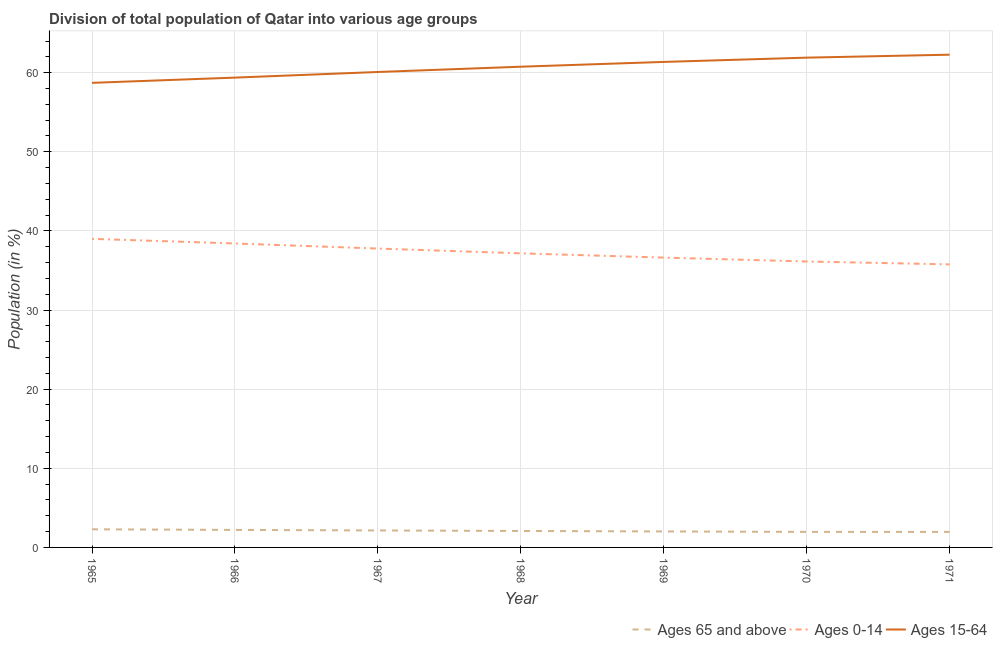How many different coloured lines are there?
Offer a terse response. 3. Does the line corresponding to percentage of population within the age-group of 65 and above intersect with the line corresponding to percentage of population within the age-group 15-64?
Keep it short and to the point. No. Is the number of lines equal to the number of legend labels?
Your answer should be compact. Yes. What is the percentage of population within the age-group 15-64 in 1966?
Your answer should be compact. 59.37. Across all years, what is the maximum percentage of population within the age-group of 65 and above?
Make the answer very short. 2.29. Across all years, what is the minimum percentage of population within the age-group of 65 and above?
Offer a terse response. 1.96. In which year was the percentage of population within the age-group of 65 and above maximum?
Keep it short and to the point. 1965. In which year was the percentage of population within the age-group 0-14 minimum?
Ensure brevity in your answer.  1971. What is the total percentage of population within the age-group 15-64 in the graph?
Offer a very short reply. 424.45. What is the difference between the percentage of population within the age-group 0-14 in 1967 and that in 1969?
Keep it short and to the point. 1.14. What is the difference between the percentage of population within the age-group 0-14 in 1971 and the percentage of population within the age-group 15-64 in 1966?
Your answer should be compact. -23.61. What is the average percentage of population within the age-group 15-64 per year?
Offer a terse response. 60.64. In the year 1969, what is the difference between the percentage of population within the age-group of 65 and above and percentage of population within the age-group 0-14?
Keep it short and to the point. -34.61. What is the ratio of the percentage of population within the age-group 15-64 in 1967 to that in 1970?
Give a very brief answer. 0.97. Is the percentage of population within the age-group 15-64 in 1965 less than that in 1971?
Ensure brevity in your answer.  Yes. What is the difference between the highest and the second highest percentage of population within the age-group 0-14?
Provide a succinct answer. 0.59. What is the difference between the highest and the lowest percentage of population within the age-group 15-64?
Give a very brief answer. 3.56. Is the percentage of population within the age-group 0-14 strictly greater than the percentage of population within the age-group of 65 and above over the years?
Ensure brevity in your answer.  Yes. How many years are there in the graph?
Offer a very short reply. 7. Are the values on the major ticks of Y-axis written in scientific E-notation?
Keep it short and to the point. No. Does the graph contain any zero values?
Your answer should be compact. No. What is the title of the graph?
Provide a succinct answer. Division of total population of Qatar into various age groups
. What is the Population (in %) of Ages 65 and above in 1965?
Give a very brief answer. 2.29. What is the Population (in %) of Ages 0-14 in 1965?
Your response must be concise. 39. What is the Population (in %) of Ages 15-64 in 1965?
Offer a terse response. 58.71. What is the Population (in %) of Ages 65 and above in 1966?
Make the answer very short. 2.21. What is the Population (in %) of Ages 0-14 in 1966?
Your response must be concise. 38.41. What is the Population (in %) in Ages 15-64 in 1966?
Offer a terse response. 59.37. What is the Population (in %) of Ages 65 and above in 1967?
Provide a succinct answer. 2.14. What is the Population (in %) in Ages 0-14 in 1967?
Your answer should be very brief. 37.77. What is the Population (in %) of Ages 15-64 in 1967?
Your response must be concise. 60.09. What is the Population (in %) of Ages 65 and above in 1968?
Your answer should be very brief. 2.08. What is the Population (in %) of Ages 0-14 in 1968?
Keep it short and to the point. 37.17. What is the Population (in %) in Ages 15-64 in 1968?
Your response must be concise. 60.75. What is the Population (in %) in Ages 65 and above in 1969?
Provide a succinct answer. 2.02. What is the Population (in %) of Ages 0-14 in 1969?
Provide a succinct answer. 36.63. What is the Population (in %) of Ages 15-64 in 1969?
Ensure brevity in your answer.  61.36. What is the Population (in %) in Ages 65 and above in 1970?
Keep it short and to the point. 1.97. What is the Population (in %) in Ages 0-14 in 1970?
Ensure brevity in your answer.  36.14. What is the Population (in %) in Ages 15-64 in 1970?
Provide a succinct answer. 61.9. What is the Population (in %) in Ages 65 and above in 1971?
Make the answer very short. 1.96. What is the Population (in %) of Ages 0-14 in 1971?
Your answer should be very brief. 35.77. What is the Population (in %) in Ages 15-64 in 1971?
Your answer should be very brief. 62.27. Across all years, what is the maximum Population (in %) of Ages 65 and above?
Provide a short and direct response. 2.29. Across all years, what is the maximum Population (in %) of Ages 0-14?
Provide a short and direct response. 39. Across all years, what is the maximum Population (in %) in Ages 15-64?
Ensure brevity in your answer.  62.27. Across all years, what is the minimum Population (in %) of Ages 65 and above?
Make the answer very short. 1.96. Across all years, what is the minimum Population (in %) of Ages 0-14?
Your answer should be very brief. 35.77. Across all years, what is the minimum Population (in %) in Ages 15-64?
Provide a succinct answer. 58.71. What is the total Population (in %) of Ages 65 and above in the graph?
Give a very brief answer. 14.68. What is the total Population (in %) in Ages 0-14 in the graph?
Make the answer very short. 260.88. What is the total Population (in %) in Ages 15-64 in the graph?
Keep it short and to the point. 424.45. What is the difference between the Population (in %) of Ages 65 and above in 1965 and that in 1966?
Your answer should be compact. 0.08. What is the difference between the Population (in %) in Ages 0-14 in 1965 and that in 1966?
Offer a terse response. 0.59. What is the difference between the Population (in %) of Ages 15-64 in 1965 and that in 1966?
Your answer should be very brief. -0.66. What is the difference between the Population (in %) of Ages 65 and above in 1965 and that in 1967?
Your answer should be very brief. 0.15. What is the difference between the Population (in %) in Ages 0-14 in 1965 and that in 1967?
Provide a succinct answer. 1.23. What is the difference between the Population (in %) in Ages 15-64 in 1965 and that in 1967?
Give a very brief answer. -1.37. What is the difference between the Population (in %) in Ages 65 and above in 1965 and that in 1968?
Your response must be concise. 0.21. What is the difference between the Population (in %) in Ages 0-14 in 1965 and that in 1968?
Offer a terse response. 1.83. What is the difference between the Population (in %) in Ages 15-64 in 1965 and that in 1968?
Your answer should be very brief. -2.04. What is the difference between the Population (in %) of Ages 65 and above in 1965 and that in 1969?
Keep it short and to the point. 0.27. What is the difference between the Population (in %) of Ages 0-14 in 1965 and that in 1969?
Provide a short and direct response. 2.37. What is the difference between the Population (in %) in Ages 15-64 in 1965 and that in 1969?
Make the answer very short. -2.64. What is the difference between the Population (in %) of Ages 65 and above in 1965 and that in 1970?
Provide a succinct answer. 0.33. What is the difference between the Population (in %) in Ages 0-14 in 1965 and that in 1970?
Ensure brevity in your answer.  2.86. What is the difference between the Population (in %) in Ages 15-64 in 1965 and that in 1970?
Your answer should be very brief. -3.19. What is the difference between the Population (in %) of Ages 65 and above in 1965 and that in 1971?
Give a very brief answer. 0.33. What is the difference between the Population (in %) in Ages 0-14 in 1965 and that in 1971?
Your answer should be very brief. 3.23. What is the difference between the Population (in %) in Ages 15-64 in 1965 and that in 1971?
Your answer should be compact. -3.56. What is the difference between the Population (in %) of Ages 65 and above in 1966 and that in 1967?
Offer a very short reply. 0.07. What is the difference between the Population (in %) of Ages 0-14 in 1966 and that in 1967?
Your answer should be very brief. 0.64. What is the difference between the Population (in %) of Ages 15-64 in 1966 and that in 1967?
Keep it short and to the point. -0.71. What is the difference between the Population (in %) of Ages 65 and above in 1966 and that in 1968?
Your response must be concise. 0.13. What is the difference between the Population (in %) of Ages 0-14 in 1966 and that in 1968?
Your response must be concise. 1.25. What is the difference between the Population (in %) in Ages 15-64 in 1966 and that in 1968?
Offer a very short reply. -1.38. What is the difference between the Population (in %) of Ages 65 and above in 1966 and that in 1969?
Keep it short and to the point. 0.19. What is the difference between the Population (in %) in Ages 0-14 in 1966 and that in 1969?
Make the answer very short. 1.79. What is the difference between the Population (in %) of Ages 15-64 in 1966 and that in 1969?
Your response must be concise. -1.98. What is the difference between the Population (in %) of Ages 65 and above in 1966 and that in 1970?
Offer a terse response. 0.25. What is the difference between the Population (in %) of Ages 0-14 in 1966 and that in 1970?
Ensure brevity in your answer.  2.28. What is the difference between the Population (in %) of Ages 15-64 in 1966 and that in 1970?
Give a very brief answer. -2.52. What is the difference between the Population (in %) in Ages 65 and above in 1966 and that in 1971?
Give a very brief answer. 0.25. What is the difference between the Population (in %) in Ages 0-14 in 1966 and that in 1971?
Your answer should be very brief. 2.64. What is the difference between the Population (in %) in Ages 15-64 in 1966 and that in 1971?
Ensure brevity in your answer.  -2.9. What is the difference between the Population (in %) in Ages 65 and above in 1967 and that in 1968?
Give a very brief answer. 0.06. What is the difference between the Population (in %) of Ages 0-14 in 1967 and that in 1968?
Make the answer very short. 0.6. What is the difference between the Population (in %) in Ages 15-64 in 1967 and that in 1968?
Ensure brevity in your answer.  -0.67. What is the difference between the Population (in %) of Ages 65 and above in 1967 and that in 1969?
Keep it short and to the point. 0.13. What is the difference between the Population (in %) in Ages 0-14 in 1967 and that in 1969?
Provide a succinct answer. 1.14. What is the difference between the Population (in %) of Ages 15-64 in 1967 and that in 1969?
Keep it short and to the point. -1.27. What is the difference between the Population (in %) in Ages 65 and above in 1967 and that in 1970?
Give a very brief answer. 0.18. What is the difference between the Population (in %) in Ages 0-14 in 1967 and that in 1970?
Ensure brevity in your answer.  1.63. What is the difference between the Population (in %) in Ages 15-64 in 1967 and that in 1970?
Offer a terse response. -1.81. What is the difference between the Population (in %) of Ages 65 and above in 1967 and that in 1971?
Provide a short and direct response. 0.18. What is the difference between the Population (in %) of Ages 0-14 in 1967 and that in 1971?
Offer a very short reply. 2. What is the difference between the Population (in %) of Ages 15-64 in 1967 and that in 1971?
Offer a very short reply. -2.19. What is the difference between the Population (in %) in Ages 65 and above in 1968 and that in 1969?
Your response must be concise. 0.06. What is the difference between the Population (in %) in Ages 0-14 in 1968 and that in 1969?
Your answer should be compact. 0.54. What is the difference between the Population (in %) of Ages 15-64 in 1968 and that in 1969?
Offer a terse response. -0.6. What is the difference between the Population (in %) of Ages 65 and above in 1968 and that in 1970?
Your answer should be compact. 0.12. What is the difference between the Population (in %) in Ages 0-14 in 1968 and that in 1970?
Provide a succinct answer. 1.03. What is the difference between the Population (in %) in Ages 15-64 in 1968 and that in 1970?
Make the answer very short. -1.15. What is the difference between the Population (in %) in Ages 65 and above in 1968 and that in 1971?
Provide a succinct answer. 0.12. What is the difference between the Population (in %) in Ages 0-14 in 1968 and that in 1971?
Make the answer very short. 1.4. What is the difference between the Population (in %) in Ages 15-64 in 1968 and that in 1971?
Make the answer very short. -1.52. What is the difference between the Population (in %) in Ages 65 and above in 1969 and that in 1970?
Keep it short and to the point. 0.05. What is the difference between the Population (in %) in Ages 0-14 in 1969 and that in 1970?
Make the answer very short. 0.49. What is the difference between the Population (in %) of Ages 15-64 in 1969 and that in 1970?
Provide a short and direct response. -0.54. What is the difference between the Population (in %) in Ages 65 and above in 1969 and that in 1971?
Keep it short and to the point. 0.06. What is the difference between the Population (in %) of Ages 0-14 in 1969 and that in 1971?
Provide a short and direct response. 0.86. What is the difference between the Population (in %) in Ages 15-64 in 1969 and that in 1971?
Offer a terse response. -0.92. What is the difference between the Population (in %) of Ages 65 and above in 1970 and that in 1971?
Offer a terse response. 0.01. What is the difference between the Population (in %) in Ages 0-14 in 1970 and that in 1971?
Provide a short and direct response. 0.37. What is the difference between the Population (in %) of Ages 15-64 in 1970 and that in 1971?
Your response must be concise. -0.37. What is the difference between the Population (in %) in Ages 65 and above in 1965 and the Population (in %) in Ages 0-14 in 1966?
Your answer should be compact. -36.12. What is the difference between the Population (in %) of Ages 65 and above in 1965 and the Population (in %) of Ages 15-64 in 1966?
Offer a very short reply. -57.08. What is the difference between the Population (in %) of Ages 0-14 in 1965 and the Population (in %) of Ages 15-64 in 1966?
Provide a succinct answer. -20.38. What is the difference between the Population (in %) in Ages 65 and above in 1965 and the Population (in %) in Ages 0-14 in 1967?
Your response must be concise. -35.48. What is the difference between the Population (in %) of Ages 65 and above in 1965 and the Population (in %) of Ages 15-64 in 1967?
Your answer should be compact. -57.79. What is the difference between the Population (in %) of Ages 0-14 in 1965 and the Population (in %) of Ages 15-64 in 1967?
Keep it short and to the point. -21.09. What is the difference between the Population (in %) in Ages 65 and above in 1965 and the Population (in %) in Ages 0-14 in 1968?
Keep it short and to the point. -34.88. What is the difference between the Population (in %) in Ages 65 and above in 1965 and the Population (in %) in Ages 15-64 in 1968?
Your response must be concise. -58.46. What is the difference between the Population (in %) in Ages 0-14 in 1965 and the Population (in %) in Ages 15-64 in 1968?
Your response must be concise. -21.75. What is the difference between the Population (in %) in Ages 65 and above in 1965 and the Population (in %) in Ages 0-14 in 1969?
Keep it short and to the point. -34.33. What is the difference between the Population (in %) in Ages 65 and above in 1965 and the Population (in %) in Ages 15-64 in 1969?
Offer a very short reply. -59.06. What is the difference between the Population (in %) of Ages 0-14 in 1965 and the Population (in %) of Ages 15-64 in 1969?
Offer a terse response. -22.36. What is the difference between the Population (in %) of Ages 65 and above in 1965 and the Population (in %) of Ages 0-14 in 1970?
Provide a short and direct response. -33.85. What is the difference between the Population (in %) of Ages 65 and above in 1965 and the Population (in %) of Ages 15-64 in 1970?
Ensure brevity in your answer.  -59.61. What is the difference between the Population (in %) in Ages 0-14 in 1965 and the Population (in %) in Ages 15-64 in 1970?
Provide a short and direct response. -22.9. What is the difference between the Population (in %) in Ages 65 and above in 1965 and the Population (in %) in Ages 0-14 in 1971?
Provide a short and direct response. -33.48. What is the difference between the Population (in %) of Ages 65 and above in 1965 and the Population (in %) of Ages 15-64 in 1971?
Your answer should be compact. -59.98. What is the difference between the Population (in %) in Ages 0-14 in 1965 and the Population (in %) in Ages 15-64 in 1971?
Keep it short and to the point. -23.27. What is the difference between the Population (in %) of Ages 65 and above in 1966 and the Population (in %) of Ages 0-14 in 1967?
Ensure brevity in your answer.  -35.56. What is the difference between the Population (in %) of Ages 65 and above in 1966 and the Population (in %) of Ages 15-64 in 1967?
Offer a terse response. -57.87. What is the difference between the Population (in %) in Ages 0-14 in 1966 and the Population (in %) in Ages 15-64 in 1967?
Offer a terse response. -21.67. What is the difference between the Population (in %) of Ages 65 and above in 1966 and the Population (in %) of Ages 0-14 in 1968?
Provide a succinct answer. -34.95. What is the difference between the Population (in %) of Ages 65 and above in 1966 and the Population (in %) of Ages 15-64 in 1968?
Offer a terse response. -58.54. What is the difference between the Population (in %) of Ages 0-14 in 1966 and the Population (in %) of Ages 15-64 in 1968?
Your answer should be compact. -22.34. What is the difference between the Population (in %) in Ages 65 and above in 1966 and the Population (in %) in Ages 0-14 in 1969?
Your response must be concise. -34.41. What is the difference between the Population (in %) of Ages 65 and above in 1966 and the Population (in %) of Ages 15-64 in 1969?
Keep it short and to the point. -59.14. What is the difference between the Population (in %) of Ages 0-14 in 1966 and the Population (in %) of Ages 15-64 in 1969?
Give a very brief answer. -22.94. What is the difference between the Population (in %) in Ages 65 and above in 1966 and the Population (in %) in Ages 0-14 in 1970?
Offer a terse response. -33.92. What is the difference between the Population (in %) of Ages 65 and above in 1966 and the Population (in %) of Ages 15-64 in 1970?
Provide a succinct answer. -59.68. What is the difference between the Population (in %) in Ages 0-14 in 1966 and the Population (in %) in Ages 15-64 in 1970?
Offer a very short reply. -23.49. What is the difference between the Population (in %) in Ages 65 and above in 1966 and the Population (in %) in Ages 0-14 in 1971?
Ensure brevity in your answer.  -33.56. What is the difference between the Population (in %) of Ages 65 and above in 1966 and the Population (in %) of Ages 15-64 in 1971?
Keep it short and to the point. -60.06. What is the difference between the Population (in %) in Ages 0-14 in 1966 and the Population (in %) in Ages 15-64 in 1971?
Offer a very short reply. -23.86. What is the difference between the Population (in %) of Ages 65 and above in 1967 and the Population (in %) of Ages 0-14 in 1968?
Ensure brevity in your answer.  -35.02. What is the difference between the Population (in %) of Ages 65 and above in 1967 and the Population (in %) of Ages 15-64 in 1968?
Keep it short and to the point. -58.61. What is the difference between the Population (in %) of Ages 0-14 in 1967 and the Population (in %) of Ages 15-64 in 1968?
Your answer should be very brief. -22.98. What is the difference between the Population (in %) of Ages 65 and above in 1967 and the Population (in %) of Ages 0-14 in 1969?
Offer a very short reply. -34.48. What is the difference between the Population (in %) in Ages 65 and above in 1967 and the Population (in %) in Ages 15-64 in 1969?
Provide a short and direct response. -59.21. What is the difference between the Population (in %) of Ages 0-14 in 1967 and the Population (in %) of Ages 15-64 in 1969?
Keep it short and to the point. -23.59. What is the difference between the Population (in %) of Ages 65 and above in 1967 and the Population (in %) of Ages 0-14 in 1970?
Ensure brevity in your answer.  -33.99. What is the difference between the Population (in %) in Ages 65 and above in 1967 and the Population (in %) in Ages 15-64 in 1970?
Offer a terse response. -59.75. What is the difference between the Population (in %) in Ages 0-14 in 1967 and the Population (in %) in Ages 15-64 in 1970?
Your answer should be very brief. -24.13. What is the difference between the Population (in %) of Ages 65 and above in 1967 and the Population (in %) of Ages 0-14 in 1971?
Keep it short and to the point. -33.62. What is the difference between the Population (in %) of Ages 65 and above in 1967 and the Population (in %) of Ages 15-64 in 1971?
Ensure brevity in your answer.  -60.13. What is the difference between the Population (in %) in Ages 0-14 in 1967 and the Population (in %) in Ages 15-64 in 1971?
Provide a succinct answer. -24.5. What is the difference between the Population (in %) of Ages 65 and above in 1968 and the Population (in %) of Ages 0-14 in 1969?
Provide a short and direct response. -34.55. What is the difference between the Population (in %) in Ages 65 and above in 1968 and the Population (in %) in Ages 15-64 in 1969?
Offer a terse response. -59.27. What is the difference between the Population (in %) in Ages 0-14 in 1968 and the Population (in %) in Ages 15-64 in 1969?
Keep it short and to the point. -24.19. What is the difference between the Population (in %) in Ages 65 and above in 1968 and the Population (in %) in Ages 0-14 in 1970?
Ensure brevity in your answer.  -34.06. What is the difference between the Population (in %) of Ages 65 and above in 1968 and the Population (in %) of Ages 15-64 in 1970?
Keep it short and to the point. -59.82. What is the difference between the Population (in %) of Ages 0-14 in 1968 and the Population (in %) of Ages 15-64 in 1970?
Provide a short and direct response. -24.73. What is the difference between the Population (in %) in Ages 65 and above in 1968 and the Population (in %) in Ages 0-14 in 1971?
Offer a terse response. -33.69. What is the difference between the Population (in %) in Ages 65 and above in 1968 and the Population (in %) in Ages 15-64 in 1971?
Make the answer very short. -60.19. What is the difference between the Population (in %) in Ages 0-14 in 1968 and the Population (in %) in Ages 15-64 in 1971?
Your answer should be compact. -25.1. What is the difference between the Population (in %) in Ages 65 and above in 1969 and the Population (in %) in Ages 0-14 in 1970?
Provide a succinct answer. -34.12. What is the difference between the Population (in %) in Ages 65 and above in 1969 and the Population (in %) in Ages 15-64 in 1970?
Make the answer very short. -59.88. What is the difference between the Population (in %) in Ages 0-14 in 1969 and the Population (in %) in Ages 15-64 in 1970?
Keep it short and to the point. -25.27. What is the difference between the Population (in %) of Ages 65 and above in 1969 and the Population (in %) of Ages 0-14 in 1971?
Offer a very short reply. -33.75. What is the difference between the Population (in %) in Ages 65 and above in 1969 and the Population (in %) in Ages 15-64 in 1971?
Provide a succinct answer. -60.25. What is the difference between the Population (in %) of Ages 0-14 in 1969 and the Population (in %) of Ages 15-64 in 1971?
Provide a succinct answer. -25.64. What is the difference between the Population (in %) of Ages 65 and above in 1970 and the Population (in %) of Ages 0-14 in 1971?
Offer a terse response. -33.8. What is the difference between the Population (in %) of Ages 65 and above in 1970 and the Population (in %) of Ages 15-64 in 1971?
Offer a very short reply. -60.3. What is the difference between the Population (in %) in Ages 0-14 in 1970 and the Population (in %) in Ages 15-64 in 1971?
Give a very brief answer. -26.13. What is the average Population (in %) of Ages 65 and above per year?
Provide a short and direct response. 2.1. What is the average Population (in %) of Ages 0-14 per year?
Your answer should be compact. 37.27. What is the average Population (in %) in Ages 15-64 per year?
Offer a very short reply. 60.64. In the year 1965, what is the difference between the Population (in %) in Ages 65 and above and Population (in %) in Ages 0-14?
Provide a succinct answer. -36.71. In the year 1965, what is the difference between the Population (in %) of Ages 65 and above and Population (in %) of Ages 15-64?
Provide a short and direct response. -56.42. In the year 1965, what is the difference between the Population (in %) in Ages 0-14 and Population (in %) in Ages 15-64?
Provide a succinct answer. -19.71. In the year 1966, what is the difference between the Population (in %) in Ages 65 and above and Population (in %) in Ages 0-14?
Keep it short and to the point. -36.2. In the year 1966, what is the difference between the Population (in %) in Ages 65 and above and Population (in %) in Ages 15-64?
Your answer should be compact. -57.16. In the year 1966, what is the difference between the Population (in %) of Ages 0-14 and Population (in %) of Ages 15-64?
Give a very brief answer. -20.96. In the year 1967, what is the difference between the Population (in %) in Ages 65 and above and Population (in %) in Ages 0-14?
Offer a very short reply. -35.63. In the year 1967, what is the difference between the Population (in %) of Ages 65 and above and Population (in %) of Ages 15-64?
Offer a very short reply. -57.94. In the year 1967, what is the difference between the Population (in %) in Ages 0-14 and Population (in %) in Ages 15-64?
Offer a terse response. -22.32. In the year 1968, what is the difference between the Population (in %) of Ages 65 and above and Population (in %) of Ages 0-14?
Give a very brief answer. -35.09. In the year 1968, what is the difference between the Population (in %) in Ages 65 and above and Population (in %) in Ages 15-64?
Offer a terse response. -58.67. In the year 1968, what is the difference between the Population (in %) in Ages 0-14 and Population (in %) in Ages 15-64?
Ensure brevity in your answer.  -23.59. In the year 1969, what is the difference between the Population (in %) in Ages 65 and above and Population (in %) in Ages 0-14?
Keep it short and to the point. -34.61. In the year 1969, what is the difference between the Population (in %) of Ages 65 and above and Population (in %) of Ages 15-64?
Offer a terse response. -59.34. In the year 1969, what is the difference between the Population (in %) of Ages 0-14 and Population (in %) of Ages 15-64?
Provide a short and direct response. -24.73. In the year 1970, what is the difference between the Population (in %) of Ages 65 and above and Population (in %) of Ages 0-14?
Your response must be concise. -34.17. In the year 1970, what is the difference between the Population (in %) in Ages 65 and above and Population (in %) in Ages 15-64?
Your answer should be very brief. -59.93. In the year 1970, what is the difference between the Population (in %) of Ages 0-14 and Population (in %) of Ages 15-64?
Provide a short and direct response. -25.76. In the year 1971, what is the difference between the Population (in %) in Ages 65 and above and Population (in %) in Ages 0-14?
Provide a short and direct response. -33.81. In the year 1971, what is the difference between the Population (in %) in Ages 65 and above and Population (in %) in Ages 15-64?
Your answer should be compact. -60.31. In the year 1971, what is the difference between the Population (in %) of Ages 0-14 and Population (in %) of Ages 15-64?
Offer a very short reply. -26.5. What is the ratio of the Population (in %) in Ages 65 and above in 1965 to that in 1966?
Provide a short and direct response. 1.04. What is the ratio of the Population (in %) of Ages 0-14 in 1965 to that in 1966?
Provide a succinct answer. 1.02. What is the ratio of the Population (in %) in Ages 15-64 in 1965 to that in 1966?
Make the answer very short. 0.99. What is the ratio of the Population (in %) in Ages 65 and above in 1965 to that in 1967?
Offer a terse response. 1.07. What is the ratio of the Population (in %) in Ages 0-14 in 1965 to that in 1967?
Your response must be concise. 1.03. What is the ratio of the Population (in %) in Ages 15-64 in 1965 to that in 1967?
Keep it short and to the point. 0.98. What is the ratio of the Population (in %) of Ages 65 and above in 1965 to that in 1968?
Give a very brief answer. 1.1. What is the ratio of the Population (in %) of Ages 0-14 in 1965 to that in 1968?
Make the answer very short. 1.05. What is the ratio of the Population (in %) of Ages 15-64 in 1965 to that in 1968?
Ensure brevity in your answer.  0.97. What is the ratio of the Population (in %) of Ages 65 and above in 1965 to that in 1969?
Your response must be concise. 1.13. What is the ratio of the Population (in %) of Ages 0-14 in 1965 to that in 1969?
Your answer should be compact. 1.06. What is the ratio of the Population (in %) of Ages 15-64 in 1965 to that in 1969?
Offer a very short reply. 0.96. What is the ratio of the Population (in %) in Ages 65 and above in 1965 to that in 1970?
Your answer should be compact. 1.17. What is the ratio of the Population (in %) in Ages 0-14 in 1965 to that in 1970?
Offer a very short reply. 1.08. What is the ratio of the Population (in %) of Ages 15-64 in 1965 to that in 1970?
Offer a very short reply. 0.95. What is the ratio of the Population (in %) of Ages 65 and above in 1965 to that in 1971?
Your answer should be very brief. 1.17. What is the ratio of the Population (in %) of Ages 0-14 in 1965 to that in 1971?
Keep it short and to the point. 1.09. What is the ratio of the Population (in %) of Ages 15-64 in 1965 to that in 1971?
Offer a very short reply. 0.94. What is the ratio of the Population (in %) of Ages 65 and above in 1966 to that in 1967?
Offer a terse response. 1.03. What is the ratio of the Population (in %) of Ages 0-14 in 1966 to that in 1967?
Give a very brief answer. 1.02. What is the ratio of the Population (in %) of Ages 65 and above in 1966 to that in 1968?
Offer a very short reply. 1.06. What is the ratio of the Population (in %) of Ages 0-14 in 1966 to that in 1968?
Your answer should be very brief. 1.03. What is the ratio of the Population (in %) of Ages 15-64 in 1966 to that in 1968?
Your answer should be compact. 0.98. What is the ratio of the Population (in %) of Ages 65 and above in 1966 to that in 1969?
Keep it short and to the point. 1.1. What is the ratio of the Population (in %) in Ages 0-14 in 1966 to that in 1969?
Your response must be concise. 1.05. What is the ratio of the Population (in %) in Ages 15-64 in 1966 to that in 1969?
Offer a very short reply. 0.97. What is the ratio of the Population (in %) of Ages 65 and above in 1966 to that in 1970?
Offer a terse response. 1.13. What is the ratio of the Population (in %) in Ages 0-14 in 1966 to that in 1970?
Provide a short and direct response. 1.06. What is the ratio of the Population (in %) of Ages 15-64 in 1966 to that in 1970?
Provide a short and direct response. 0.96. What is the ratio of the Population (in %) in Ages 65 and above in 1966 to that in 1971?
Your answer should be very brief. 1.13. What is the ratio of the Population (in %) in Ages 0-14 in 1966 to that in 1971?
Keep it short and to the point. 1.07. What is the ratio of the Population (in %) in Ages 15-64 in 1966 to that in 1971?
Offer a very short reply. 0.95. What is the ratio of the Population (in %) of Ages 65 and above in 1967 to that in 1968?
Keep it short and to the point. 1.03. What is the ratio of the Population (in %) in Ages 0-14 in 1967 to that in 1968?
Give a very brief answer. 1.02. What is the ratio of the Population (in %) of Ages 65 and above in 1967 to that in 1969?
Offer a very short reply. 1.06. What is the ratio of the Population (in %) in Ages 0-14 in 1967 to that in 1969?
Give a very brief answer. 1.03. What is the ratio of the Population (in %) in Ages 15-64 in 1967 to that in 1969?
Make the answer very short. 0.98. What is the ratio of the Population (in %) in Ages 65 and above in 1967 to that in 1970?
Provide a succinct answer. 1.09. What is the ratio of the Population (in %) in Ages 0-14 in 1967 to that in 1970?
Provide a succinct answer. 1.05. What is the ratio of the Population (in %) of Ages 15-64 in 1967 to that in 1970?
Offer a terse response. 0.97. What is the ratio of the Population (in %) in Ages 65 and above in 1967 to that in 1971?
Your answer should be compact. 1.09. What is the ratio of the Population (in %) of Ages 0-14 in 1967 to that in 1971?
Offer a very short reply. 1.06. What is the ratio of the Population (in %) of Ages 15-64 in 1967 to that in 1971?
Your answer should be very brief. 0.96. What is the ratio of the Population (in %) in Ages 65 and above in 1968 to that in 1969?
Offer a very short reply. 1.03. What is the ratio of the Population (in %) in Ages 0-14 in 1968 to that in 1969?
Provide a short and direct response. 1.01. What is the ratio of the Population (in %) of Ages 15-64 in 1968 to that in 1969?
Ensure brevity in your answer.  0.99. What is the ratio of the Population (in %) in Ages 65 and above in 1968 to that in 1970?
Your answer should be compact. 1.06. What is the ratio of the Population (in %) in Ages 0-14 in 1968 to that in 1970?
Give a very brief answer. 1.03. What is the ratio of the Population (in %) of Ages 15-64 in 1968 to that in 1970?
Provide a succinct answer. 0.98. What is the ratio of the Population (in %) of Ages 65 and above in 1968 to that in 1971?
Ensure brevity in your answer.  1.06. What is the ratio of the Population (in %) of Ages 0-14 in 1968 to that in 1971?
Keep it short and to the point. 1.04. What is the ratio of the Population (in %) of Ages 15-64 in 1968 to that in 1971?
Provide a short and direct response. 0.98. What is the ratio of the Population (in %) in Ages 65 and above in 1969 to that in 1970?
Give a very brief answer. 1.03. What is the ratio of the Population (in %) of Ages 0-14 in 1969 to that in 1970?
Ensure brevity in your answer.  1.01. What is the ratio of the Population (in %) of Ages 65 and above in 1969 to that in 1971?
Your answer should be compact. 1.03. What is the ratio of the Population (in %) of Ages 0-14 in 1969 to that in 1971?
Provide a succinct answer. 1.02. What is the ratio of the Population (in %) of Ages 0-14 in 1970 to that in 1971?
Your response must be concise. 1.01. What is the ratio of the Population (in %) in Ages 15-64 in 1970 to that in 1971?
Provide a succinct answer. 0.99. What is the difference between the highest and the second highest Population (in %) in Ages 65 and above?
Provide a succinct answer. 0.08. What is the difference between the highest and the second highest Population (in %) of Ages 0-14?
Provide a short and direct response. 0.59. What is the difference between the highest and the second highest Population (in %) of Ages 15-64?
Provide a short and direct response. 0.37. What is the difference between the highest and the lowest Population (in %) in Ages 65 and above?
Your answer should be very brief. 0.33. What is the difference between the highest and the lowest Population (in %) in Ages 0-14?
Give a very brief answer. 3.23. What is the difference between the highest and the lowest Population (in %) of Ages 15-64?
Keep it short and to the point. 3.56. 